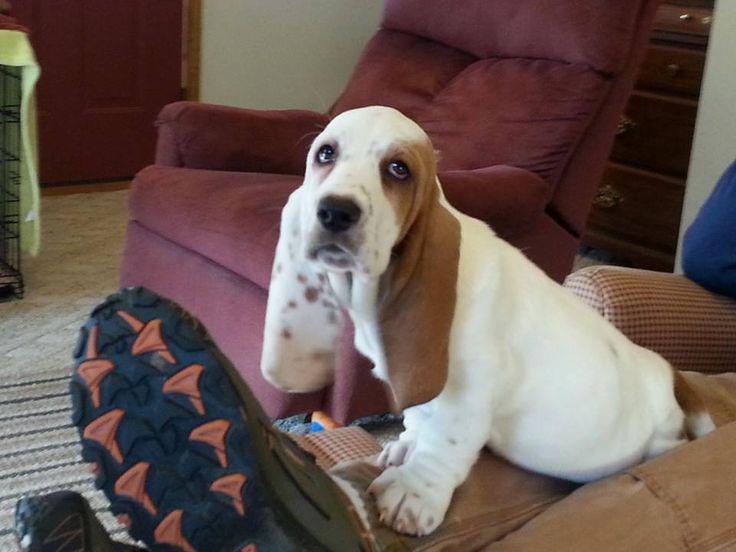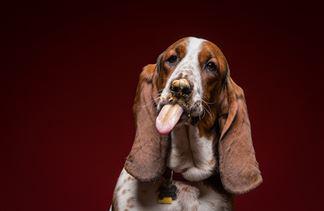The first image is the image on the left, the second image is the image on the right. Considering the images on both sides, is "A dog is eating in both images," valid? Answer yes or no. No. 